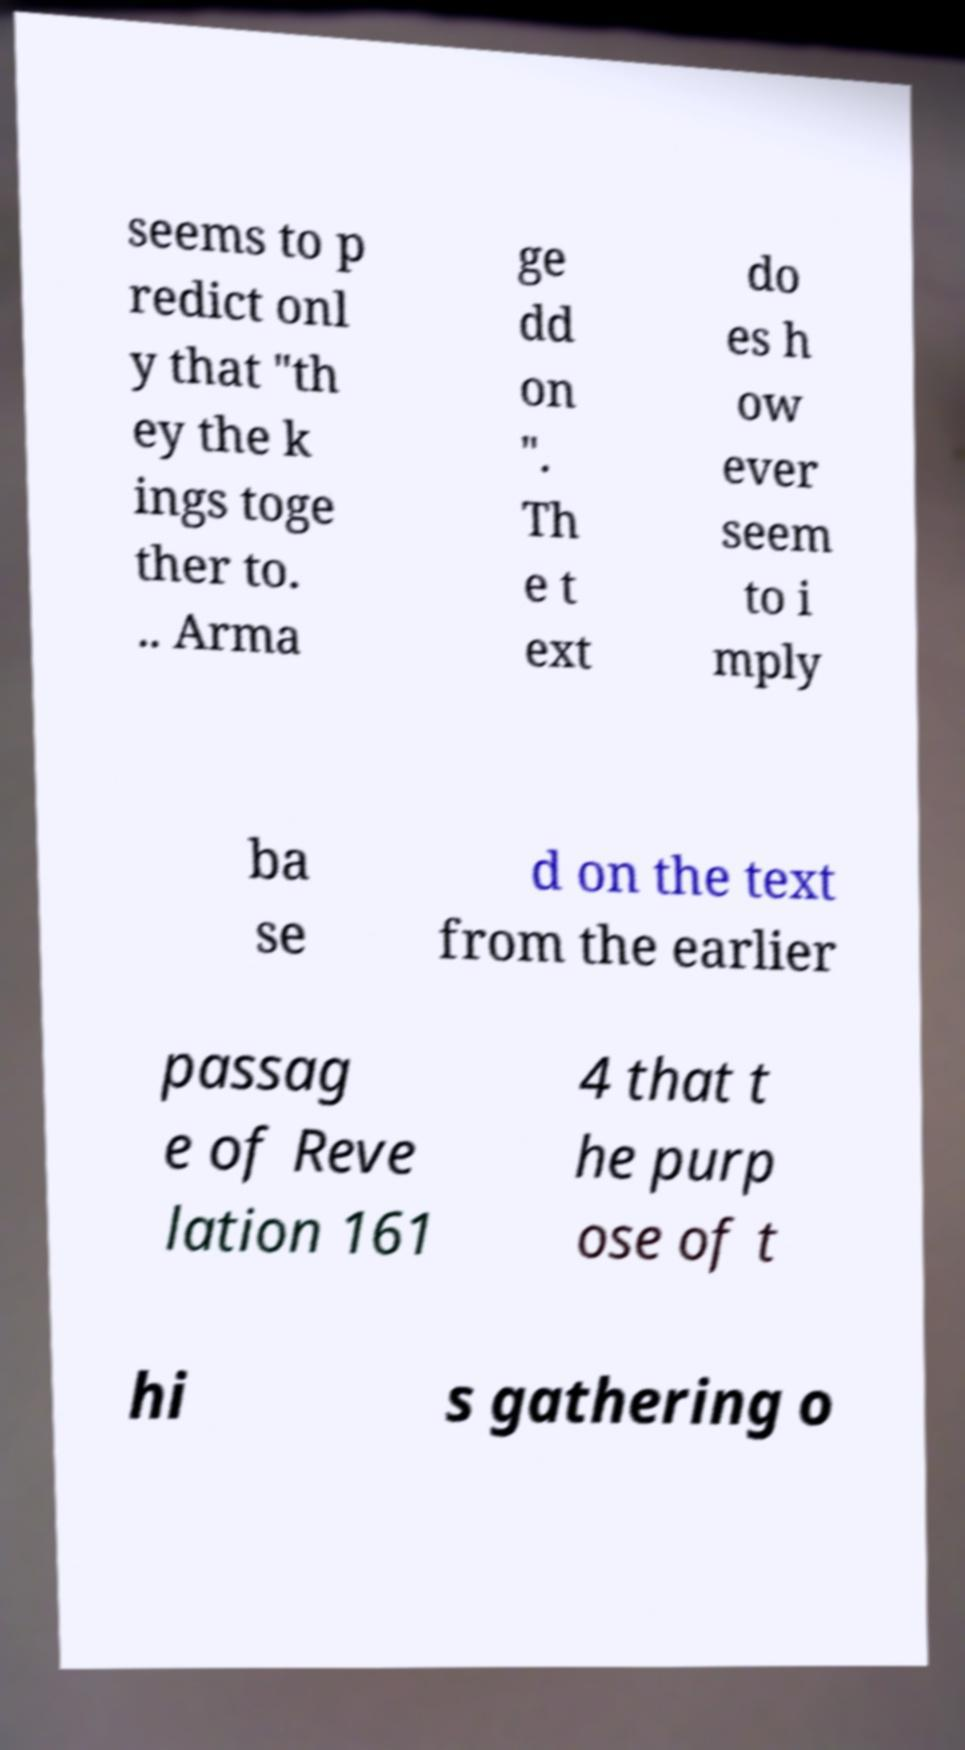Please identify and transcribe the text found in this image. seems to p redict onl y that "th ey the k ings toge ther to. .. Arma ge dd on ". Th e t ext do es h ow ever seem to i mply ba se d on the text from the earlier passag e of Reve lation 161 4 that t he purp ose of t hi s gathering o 